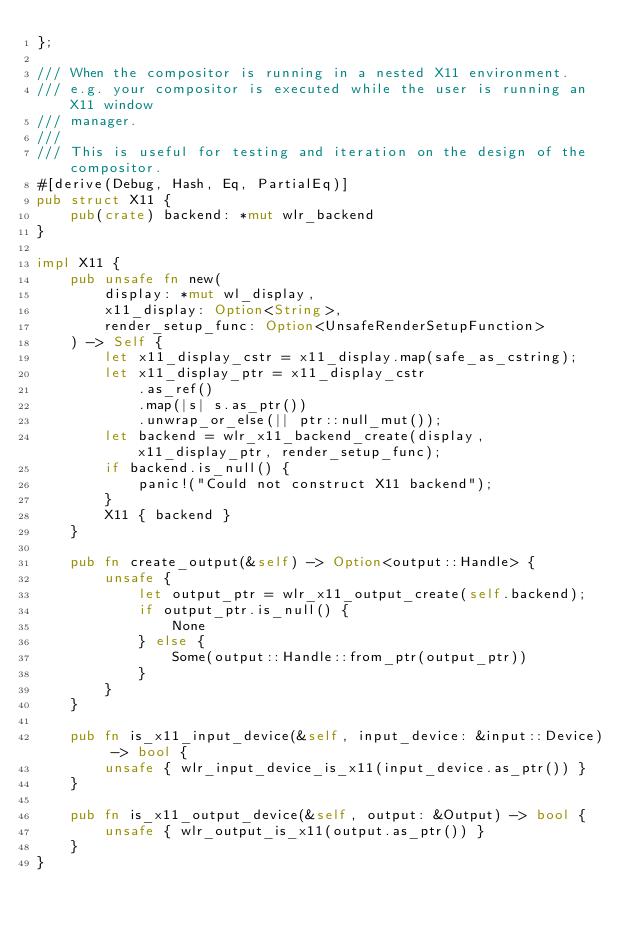Convert code to text. <code><loc_0><loc_0><loc_500><loc_500><_Rust_>};

/// When the compositor is running in a nested X11 environment.
/// e.g. your compositor is executed while the user is running an X11 window
/// manager.
///
/// This is useful for testing and iteration on the design of the compositor.
#[derive(Debug, Hash, Eq, PartialEq)]
pub struct X11 {
    pub(crate) backend: *mut wlr_backend
}

impl X11 {
    pub unsafe fn new(
        display: *mut wl_display,
        x11_display: Option<String>,
        render_setup_func: Option<UnsafeRenderSetupFunction>
    ) -> Self {
        let x11_display_cstr = x11_display.map(safe_as_cstring);
        let x11_display_ptr = x11_display_cstr
            .as_ref()
            .map(|s| s.as_ptr())
            .unwrap_or_else(|| ptr::null_mut());
        let backend = wlr_x11_backend_create(display, x11_display_ptr, render_setup_func);
        if backend.is_null() {
            panic!("Could not construct X11 backend");
        }
        X11 { backend }
    }

    pub fn create_output(&self) -> Option<output::Handle> {
        unsafe {
            let output_ptr = wlr_x11_output_create(self.backend);
            if output_ptr.is_null() {
                None
            } else {
                Some(output::Handle::from_ptr(output_ptr))
            }
        }
    }

    pub fn is_x11_input_device(&self, input_device: &input::Device) -> bool {
        unsafe { wlr_input_device_is_x11(input_device.as_ptr()) }
    }

    pub fn is_x11_output_device(&self, output: &Output) -> bool {
        unsafe { wlr_output_is_x11(output.as_ptr()) }
    }
}
</code> 